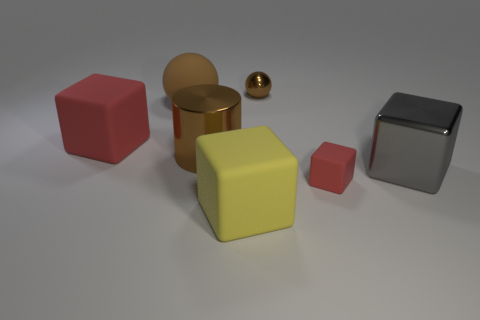How would you describe the colors of the objects and the mood they convey? The objects exhibit a range of colors, including red, yellow, brown, and silver. These colors are muted and not overly vibrant, which, along with the soft lighting and neutral background, convey a calm and serene mood. 